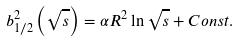<formula> <loc_0><loc_0><loc_500><loc_500>b _ { 1 / 2 } ^ { 2 } \left ( \sqrt { s } \right ) = \alpha R ^ { 2 } \ln \sqrt { s } + C o n s t .</formula> 